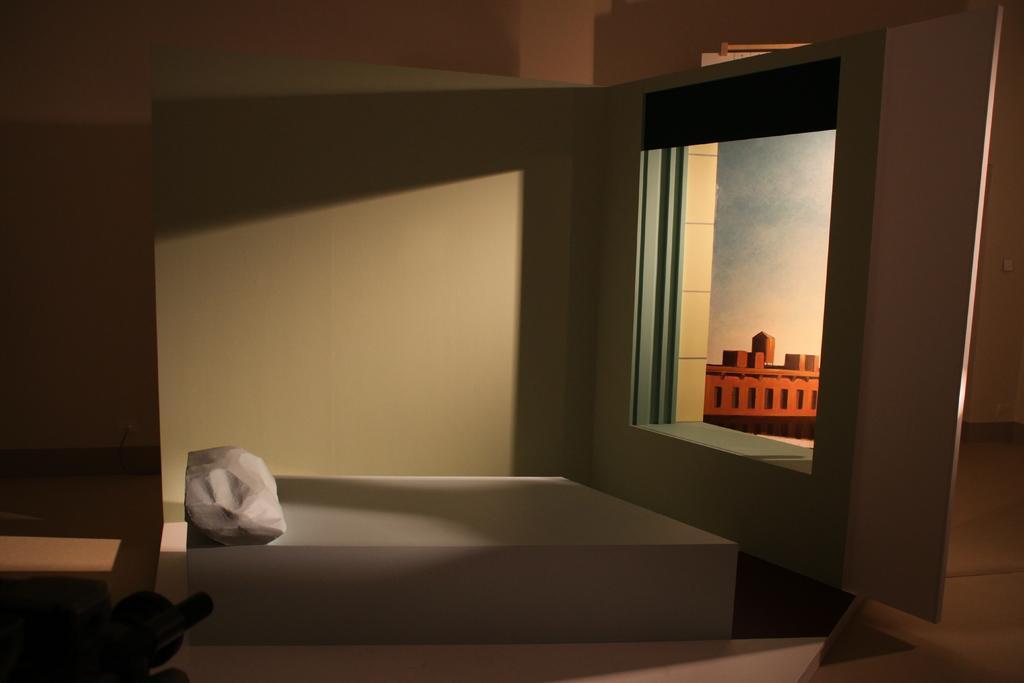Could you give a brief overview of what you see in this image? The image is taken in the room. In the center of the image we can see a bench. On the right there is a wall and we can see a painting. At the bottom there is floor. 